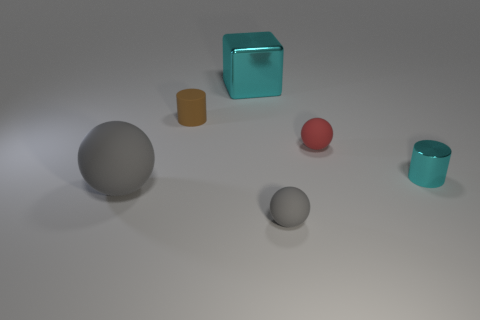Do the big thing that is on the left side of the large cyan cube and the tiny thing in front of the cyan cylinder have the same shape?
Keep it short and to the point. Yes. The large metal thing has what color?
Give a very brief answer. Cyan. How many matte objects are either cyan cylinders or blocks?
Provide a short and direct response. 0. There is another tiny thing that is the same shape as the tiny cyan metallic thing; what color is it?
Offer a very short reply. Brown. Are there any large green metallic cubes?
Offer a very short reply. No. Is the cyan thing that is behind the tiny red ball made of the same material as the gray sphere that is left of the large metal thing?
Your answer should be compact. No. The small shiny object that is the same color as the metallic block is what shape?
Keep it short and to the point. Cylinder. What number of objects are either objects that are behind the large gray rubber ball or balls that are right of the big rubber thing?
Give a very brief answer. 5. There is a object in front of the big ball; does it have the same color as the cylinder on the left side of the shiny cylinder?
Make the answer very short. No. There is a matte thing that is both in front of the small cyan metal cylinder and behind the tiny gray object; what is its shape?
Your answer should be very brief. Sphere. 